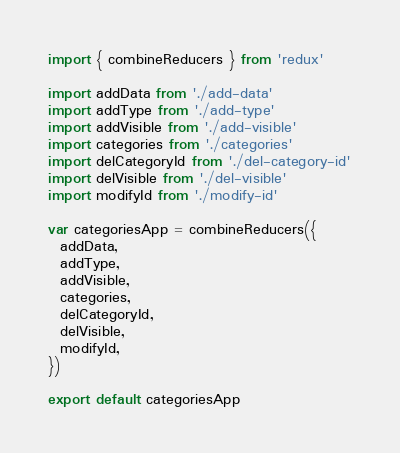<code> <loc_0><loc_0><loc_500><loc_500><_JavaScript_>import { combineReducers } from 'redux'

import addData from './add-data'
import addType from './add-type'
import addVisible from './add-visible'
import categories from './categories'
import delCategoryId from './del-category-id'
import delVisible from './del-visible'
import modifyId from './modify-id'

var categoriesApp = combineReducers({
  addData,
  addType,
  addVisible,
  categories,
  delCategoryId,
  delVisible,
  modifyId,
})

export default categoriesApp
</code> 